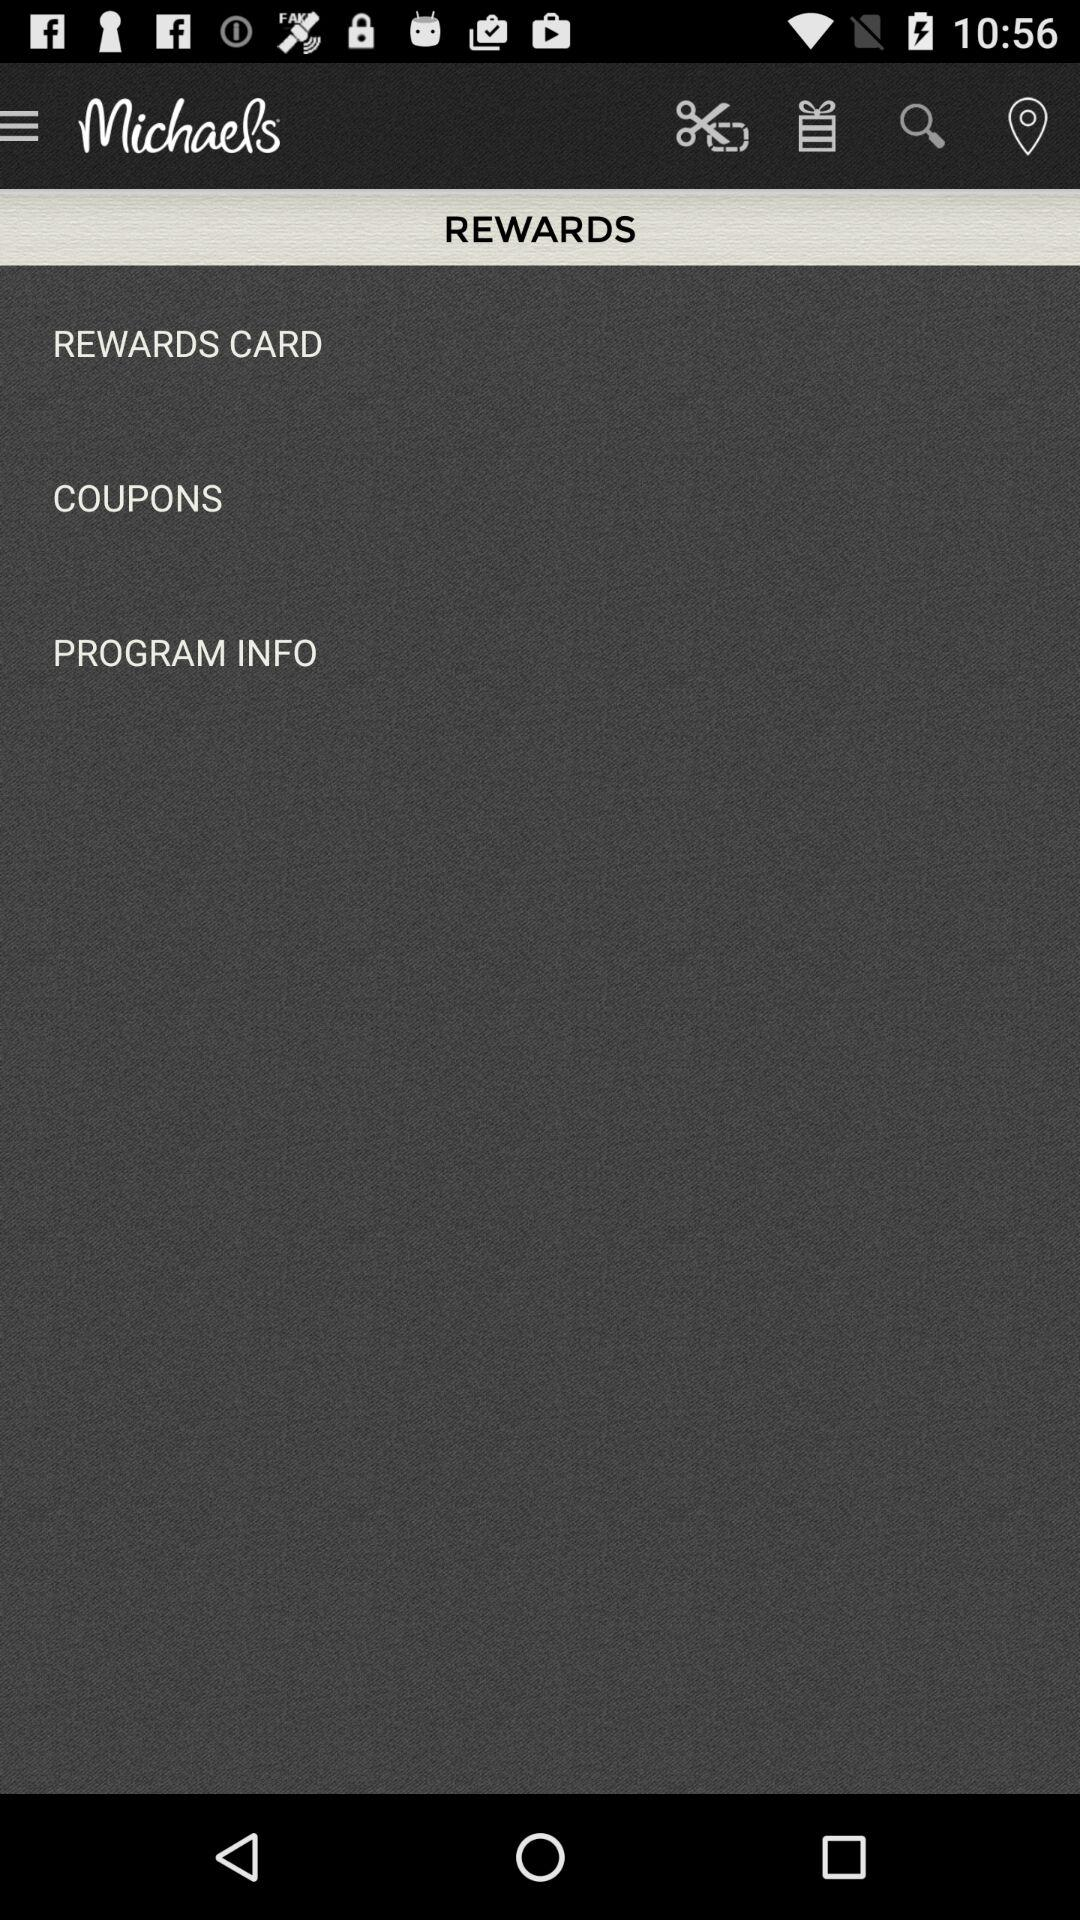How many coupons are there?
When the provided information is insufficient, respond with <no answer>. <no answer> 